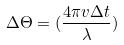<formula> <loc_0><loc_0><loc_500><loc_500>\Delta \Theta = ( \frac { 4 \pi v \Delta t } { \lambda } )</formula> 